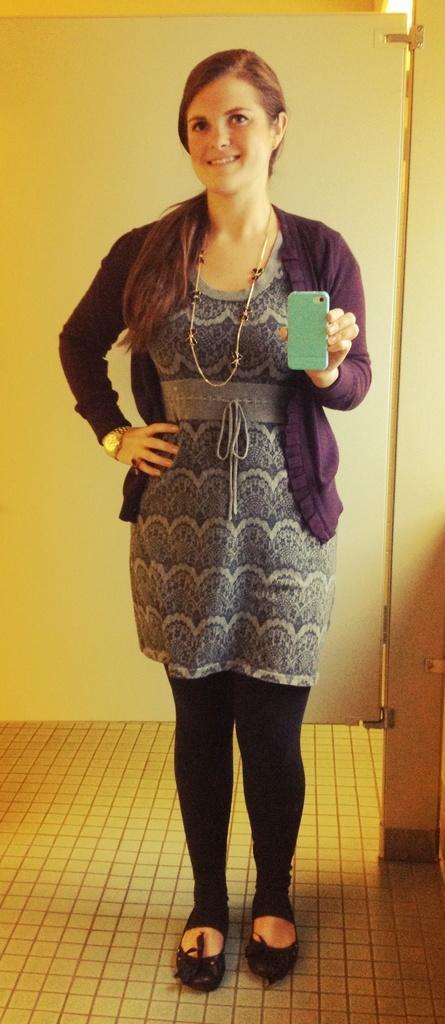How would you summarize this image in a sentence or two? A woman is standing holding a mobile phone and there is a door at the back. 